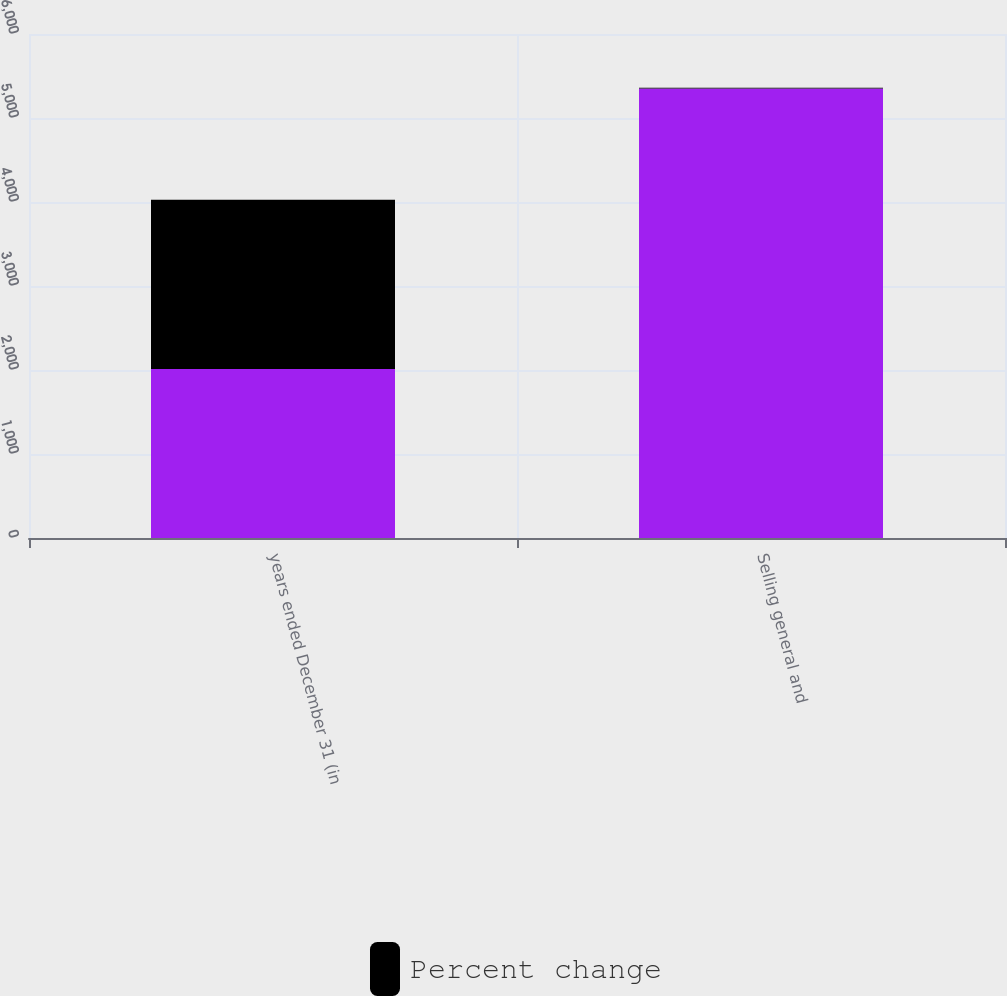Convert chart to OTSL. <chart><loc_0><loc_0><loc_500><loc_500><stacked_bar_chart><ecel><fcel>years ended December 31 (in<fcel>Selling general and<nl><fcel>nan<fcel>2013<fcel>5352<nl><fcel>Percent change<fcel>2013<fcel>7<nl></chart> 